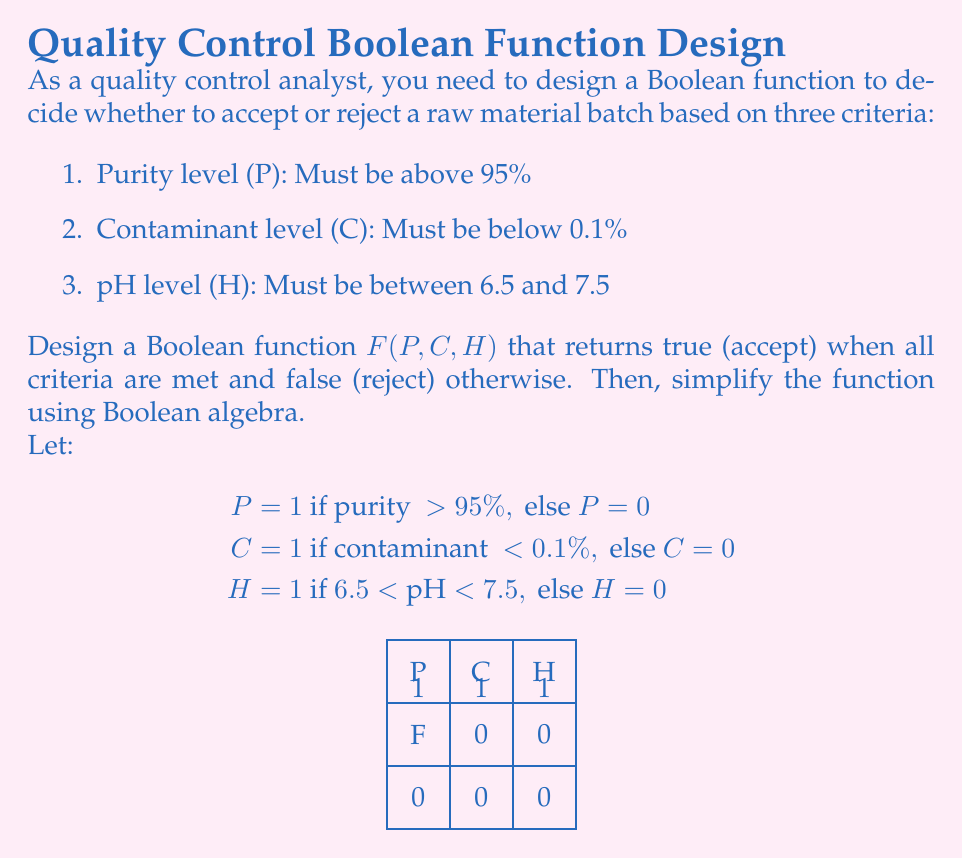Provide a solution to this math problem. Let's approach this step-by-step:

1) First, we need to write the Boolean function based on the given criteria:

   $F(P, C, H) = P \cdot C \cdot H$

   This is because we need all three conditions to be true (1) for the batch to be accepted.

2) Now, let's create a truth table for this function:

   P | C | H | F
   ---------------
   0 | 0 | 0 | 0
   0 | 0 | 1 | 0
   0 | 1 | 0 | 0
   0 | 1 | 1 | 0
   1 | 0 | 0 | 0
   1 | 0 | 1 | 0
   1 | 1 | 0 | 0
   1 | 1 | 1 | 1

3) From the truth table, we can see that the function is already in its simplest form. It's the logical AND of all three variables.

4) We can verify this using Boolean algebra laws:

   $F(P, C, H) = P \cdot C \cdot H$

   This expression cannot be simplified further because:
   - It's already in product-of-sums form
   - There are no common terms to factor out
   - No Boolean algebra law can reduce this expression

5) Therefore, the final simplified Boolean function is:

   $F(P, C, H) = P \cdot C \cdot H$

This function will return 1 (accept) only when all three criteria are met (P = 1, C = 1, and H = 1), and 0 (reject) in all other cases.
Answer: $F(P, C, H) = P \cdot C \cdot H$ 